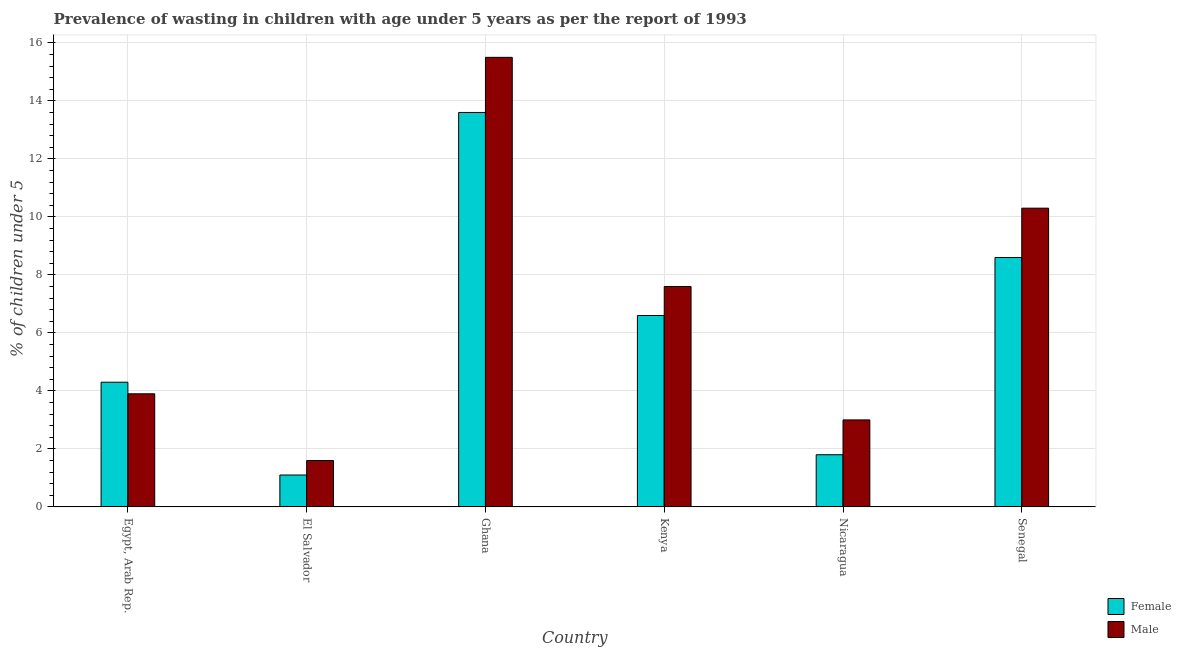How many different coloured bars are there?
Provide a succinct answer. 2. Are the number of bars on each tick of the X-axis equal?
Your answer should be very brief. Yes. How many bars are there on the 6th tick from the left?
Offer a very short reply. 2. What is the label of the 4th group of bars from the left?
Make the answer very short. Kenya. What is the percentage of undernourished female children in Ghana?
Provide a succinct answer. 13.6. Across all countries, what is the maximum percentage of undernourished female children?
Your response must be concise. 13.6. Across all countries, what is the minimum percentage of undernourished male children?
Provide a succinct answer. 1.6. In which country was the percentage of undernourished female children minimum?
Keep it short and to the point. El Salvador. What is the total percentage of undernourished male children in the graph?
Provide a short and direct response. 41.9. What is the difference between the percentage of undernourished female children in Ghana and that in Nicaragua?
Provide a succinct answer. 11.8. What is the difference between the percentage of undernourished female children in Ghana and the percentage of undernourished male children in Nicaragua?
Your answer should be very brief. 10.6. What is the average percentage of undernourished female children per country?
Your answer should be compact. 6. In how many countries, is the percentage of undernourished female children greater than 9.2 %?
Offer a terse response. 1. What is the ratio of the percentage of undernourished female children in Ghana to that in Senegal?
Your answer should be compact. 1.58. Is the percentage of undernourished male children in Egypt, Arab Rep. less than that in Senegal?
Offer a very short reply. Yes. Is the difference between the percentage of undernourished male children in Egypt, Arab Rep. and Nicaragua greater than the difference between the percentage of undernourished female children in Egypt, Arab Rep. and Nicaragua?
Provide a short and direct response. No. What is the difference between the highest and the second highest percentage of undernourished female children?
Give a very brief answer. 5. What is the difference between the highest and the lowest percentage of undernourished male children?
Make the answer very short. 13.9. In how many countries, is the percentage of undernourished female children greater than the average percentage of undernourished female children taken over all countries?
Give a very brief answer. 3. What does the 2nd bar from the left in Egypt, Arab Rep. represents?
Offer a terse response. Male. How many countries are there in the graph?
Your answer should be very brief. 6. Where does the legend appear in the graph?
Provide a short and direct response. Bottom right. How many legend labels are there?
Give a very brief answer. 2. What is the title of the graph?
Provide a succinct answer. Prevalence of wasting in children with age under 5 years as per the report of 1993. Does "Arms exports" appear as one of the legend labels in the graph?
Provide a short and direct response. No. What is the label or title of the X-axis?
Your answer should be very brief. Country. What is the label or title of the Y-axis?
Your answer should be compact.  % of children under 5. What is the  % of children under 5 of Female in Egypt, Arab Rep.?
Offer a terse response. 4.3. What is the  % of children under 5 of Male in Egypt, Arab Rep.?
Offer a terse response. 3.9. What is the  % of children under 5 in Female in El Salvador?
Ensure brevity in your answer.  1.1. What is the  % of children under 5 in Male in El Salvador?
Give a very brief answer. 1.6. What is the  % of children under 5 of Female in Ghana?
Make the answer very short. 13.6. What is the  % of children under 5 of Male in Ghana?
Your answer should be compact. 15.5. What is the  % of children under 5 in Female in Kenya?
Give a very brief answer. 6.6. What is the  % of children under 5 in Male in Kenya?
Offer a very short reply. 7.6. What is the  % of children under 5 in Female in Nicaragua?
Provide a succinct answer. 1.8. What is the  % of children under 5 in Female in Senegal?
Provide a succinct answer. 8.6. What is the  % of children under 5 in Male in Senegal?
Make the answer very short. 10.3. Across all countries, what is the maximum  % of children under 5 of Female?
Offer a terse response. 13.6. Across all countries, what is the maximum  % of children under 5 in Male?
Offer a terse response. 15.5. Across all countries, what is the minimum  % of children under 5 of Female?
Your answer should be very brief. 1.1. Across all countries, what is the minimum  % of children under 5 of Male?
Offer a very short reply. 1.6. What is the total  % of children under 5 in Female in the graph?
Your response must be concise. 36. What is the total  % of children under 5 of Male in the graph?
Your answer should be compact. 41.9. What is the difference between the  % of children under 5 in Female in Egypt, Arab Rep. and that in El Salvador?
Your response must be concise. 3.2. What is the difference between the  % of children under 5 of Female in Egypt, Arab Rep. and that in Ghana?
Your response must be concise. -9.3. What is the difference between the  % of children under 5 in Male in Egypt, Arab Rep. and that in Ghana?
Provide a short and direct response. -11.6. What is the difference between the  % of children under 5 of Male in Egypt, Arab Rep. and that in Kenya?
Your answer should be compact. -3.7. What is the difference between the  % of children under 5 of Male in Egypt, Arab Rep. and that in Nicaragua?
Provide a succinct answer. 0.9. What is the difference between the  % of children under 5 in Female in Egypt, Arab Rep. and that in Senegal?
Your answer should be very brief. -4.3. What is the difference between the  % of children under 5 in Female in El Salvador and that in Nicaragua?
Ensure brevity in your answer.  -0.7. What is the difference between the  % of children under 5 in Male in Ghana and that in Kenya?
Provide a succinct answer. 7.9. What is the difference between the  % of children under 5 of Female in Ghana and that in Nicaragua?
Your answer should be very brief. 11.8. What is the difference between the  % of children under 5 of Male in Kenya and that in Nicaragua?
Offer a very short reply. 4.6. What is the difference between the  % of children under 5 in Female in Kenya and that in Senegal?
Give a very brief answer. -2. What is the difference between the  % of children under 5 of Female in Nicaragua and that in Senegal?
Ensure brevity in your answer.  -6.8. What is the difference between the  % of children under 5 of Female in Egypt, Arab Rep. and the  % of children under 5 of Male in El Salvador?
Offer a terse response. 2.7. What is the difference between the  % of children under 5 in Female in Egypt, Arab Rep. and the  % of children under 5 in Male in Kenya?
Your answer should be very brief. -3.3. What is the difference between the  % of children under 5 in Female in Egypt, Arab Rep. and the  % of children under 5 in Male in Senegal?
Offer a very short reply. -6. What is the difference between the  % of children under 5 in Female in El Salvador and the  % of children under 5 in Male in Ghana?
Your answer should be very brief. -14.4. What is the difference between the  % of children under 5 in Female in El Salvador and the  % of children under 5 in Male in Kenya?
Give a very brief answer. -6.5. What is the average  % of children under 5 of Female per country?
Your answer should be very brief. 6. What is the average  % of children under 5 of Male per country?
Keep it short and to the point. 6.98. What is the difference between the  % of children under 5 of Female and  % of children under 5 of Male in Egypt, Arab Rep.?
Your answer should be compact. 0.4. What is the difference between the  % of children under 5 in Female and  % of children under 5 in Male in Ghana?
Keep it short and to the point. -1.9. What is the difference between the  % of children under 5 of Female and  % of children under 5 of Male in Kenya?
Offer a terse response. -1. What is the difference between the  % of children under 5 of Female and  % of children under 5 of Male in Nicaragua?
Give a very brief answer. -1.2. What is the ratio of the  % of children under 5 in Female in Egypt, Arab Rep. to that in El Salvador?
Offer a terse response. 3.91. What is the ratio of the  % of children under 5 of Male in Egypt, Arab Rep. to that in El Salvador?
Provide a short and direct response. 2.44. What is the ratio of the  % of children under 5 in Female in Egypt, Arab Rep. to that in Ghana?
Keep it short and to the point. 0.32. What is the ratio of the  % of children under 5 in Male in Egypt, Arab Rep. to that in Ghana?
Provide a succinct answer. 0.25. What is the ratio of the  % of children under 5 in Female in Egypt, Arab Rep. to that in Kenya?
Make the answer very short. 0.65. What is the ratio of the  % of children under 5 of Male in Egypt, Arab Rep. to that in Kenya?
Provide a succinct answer. 0.51. What is the ratio of the  % of children under 5 in Female in Egypt, Arab Rep. to that in Nicaragua?
Your answer should be compact. 2.39. What is the ratio of the  % of children under 5 of Male in Egypt, Arab Rep. to that in Nicaragua?
Your answer should be very brief. 1.3. What is the ratio of the  % of children under 5 in Male in Egypt, Arab Rep. to that in Senegal?
Make the answer very short. 0.38. What is the ratio of the  % of children under 5 of Female in El Salvador to that in Ghana?
Keep it short and to the point. 0.08. What is the ratio of the  % of children under 5 of Male in El Salvador to that in Ghana?
Offer a terse response. 0.1. What is the ratio of the  % of children under 5 in Female in El Salvador to that in Kenya?
Keep it short and to the point. 0.17. What is the ratio of the  % of children under 5 of Male in El Salvador to that in Kenya?
Make the answer very short. 0.21. What is the ratio of the  % of children under 5 of Female in El Salvador to that in Nicaragua?
Your response must be concise. 0.61. What is the ratio of the  % of children under 5 of Male in El Salvador to that in Nicaragua?
Offer a terse response. 0.53. What is the ratio of the  % of children under 5 of Female in El Salvador to that in Senegal?
Your answer should be very brief. 0.13. What is the ratio of the  % of children under 5 of Male in El Salvador to that in Senegal?
Offer a very short reply. 0.16. What is the ratio of the  % of children under 5 of Female in Ghana to that in Kenya?
Ensure brevity in your answer.  2.06. What is the ratio of the  % of children under 5 in Male in Ghana to that in Kenya?
Ensure brevity in your answer.  2.04. What is the ratio of the  % of children under 5 in Female in Ghana to that in Nicaragua?
Your answer should be compact. 7.56. What is the ratio of the  % of children under 5 in Male in Ghana to that in Nicaragua?
Give a very brief answer. 5.17. What is the ratio of the  % of children under 5 of Female in Ghana to that in Senegal?
Your answer should be compact. 1.58. What is the ratio of the  % of children under 5 of Male in Ghana to that in Senegal?
Provide a short and direct response. 1.5. What is the ratio of the  % of children under 5 in Female in Kenya to that in Nicaragua?
Give a very brief answer. 3.67. What is the ratio of the  % of children under 5 in Male in Kenya to that in Nicaragua?
Your answer should be compact. 2.53. What is the ratio of the  % of children under 5 in Female in Kenya to that in Senegal?
Your response must be concise. 0.77. What is the ratio of the  % of children under 5 of Male in Kenya to that in Senegal?
Your response must be concise. 0.74. What is the ratio of the  % of children under 5 of Female in Nicaragua to that in Senegal?
Offer a very short reply. 0.21. What is the ratio of the  % of children under 5 in Male in Nicaragua to that in Senegal?
Offer a very short reply. 0.29. What is the difference between the highest and the second highest  % of children under 5 in Female?
Keep it short and to the point. 5. 